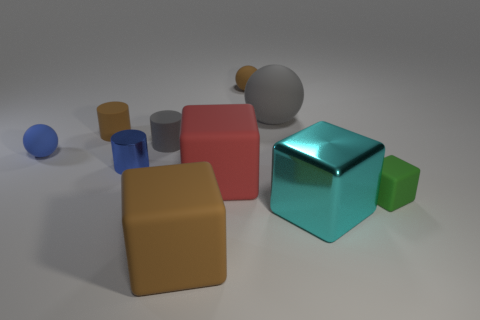Is the color of the small matte sphere that is to the left of the tiny brown rubber ball the same as the metal thing right of the small brown rubber sphere?
Your answer should be very brief. No. Are there any other things that are the same color as the tiny metallic object?
Your answer should be very brief. Yes. Are there fewer big rubber things that are in front of the small cube than large purple objects?
Provide a short and direct response. No. How many tiny cyan metal cubes are there?
Give a very brief answer. 0. There is a big red thing; does it have the same shape as the brown object on the right side of the large brown cube?
Provide a succinct answer. No. Are there fewer brown cubes that are on the right side of the brown matte ball than big matte things that are to the right of the big gray matte thing?
Offer a terse response. No. Is there anything else that has the same shape as the cyan shiny object?
Your response must be concise. Yes. Is the shape of the blue metallic object the same as the green matte object?
Ensure brevity in your answer.  No. Is there any other thing that is the same material as the small green block?
Give a very brief answer. Yes. How big is the brown cube?
Make the answer very short. Large. 